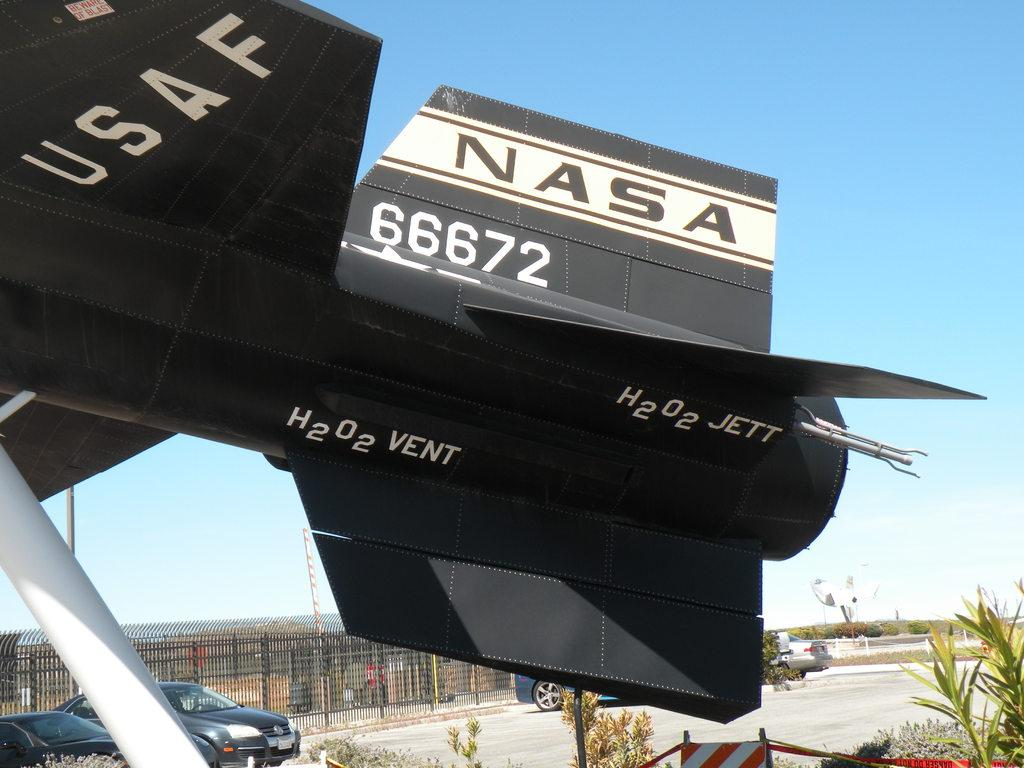Provide a one-sentence caption for the provided image. A USAF aircraft with NASA 66672 on the tail. 